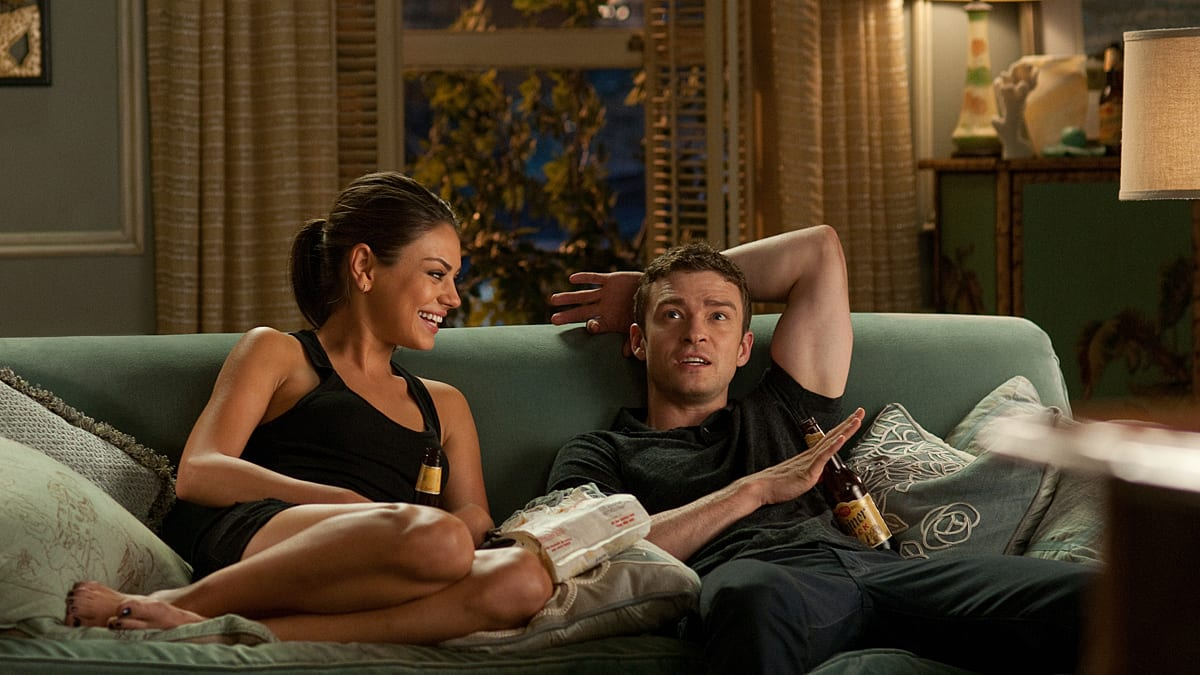Look at their expressions and body language. What do these tell us about their relationship? The casual yet intimate arrangement on the couch, with both individuals holding relaxed poses and sharing smiles, suggests a deep comfort and familiarity with each other. Their expressions, especially Justin's surprised look and Mila's joyful smile, indicate a dynamic of playful banter. This comfort and engagement typically point to a close friendship or a relationship where both parties enjoy each other’s company immensely, possibly indicating they share a bond that includes a great deal of trust and mutual enjoyment. 